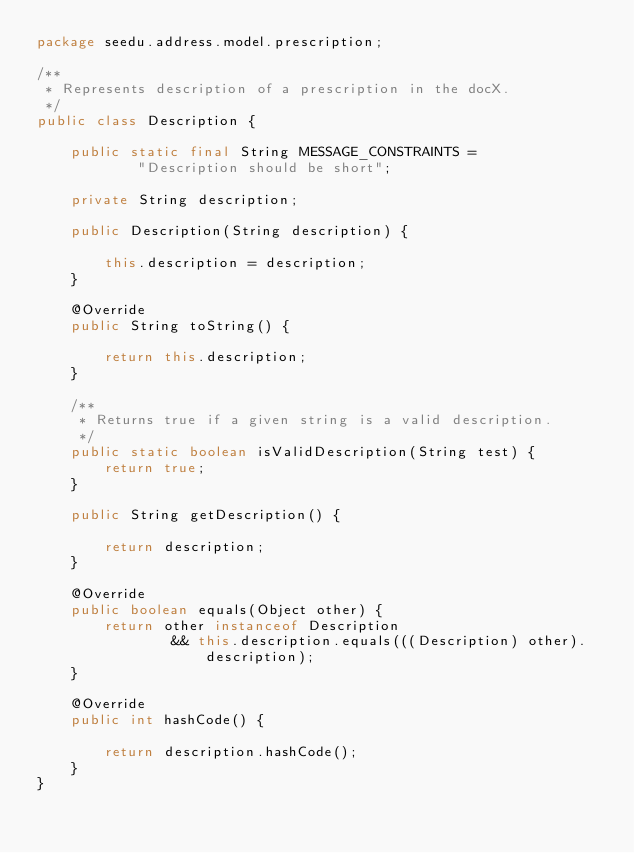Convert code to text. <code><loc_0><loc_0><loc_500><loc_500><_Java_>package seedu.address.model.prescription;

/**
 * Represents description of a prescription in the docX.
 */
public class Description {

    public static final String MESSAGE_CONSTRAINTS =
            "Description should be short";

    private String description;

    public Description(String description) {

        this.description = description;
    }

    @Override
    public String toString() {

        return this.description;
    }

    /**
     * Returns true if a given string is a valid description.
     */
    public static boolean isValidDescription(String test) {
        return true;
    }

    public String getDescription() {

        return description;
    }

    @Override
    public boolean equals(Object other) {
        return other instanceof Description
                && this.description.equals(((Description) other).description);
    }

    @Override
    public int hashCode() {

        return description.hashCode();
    }
}
</code> 